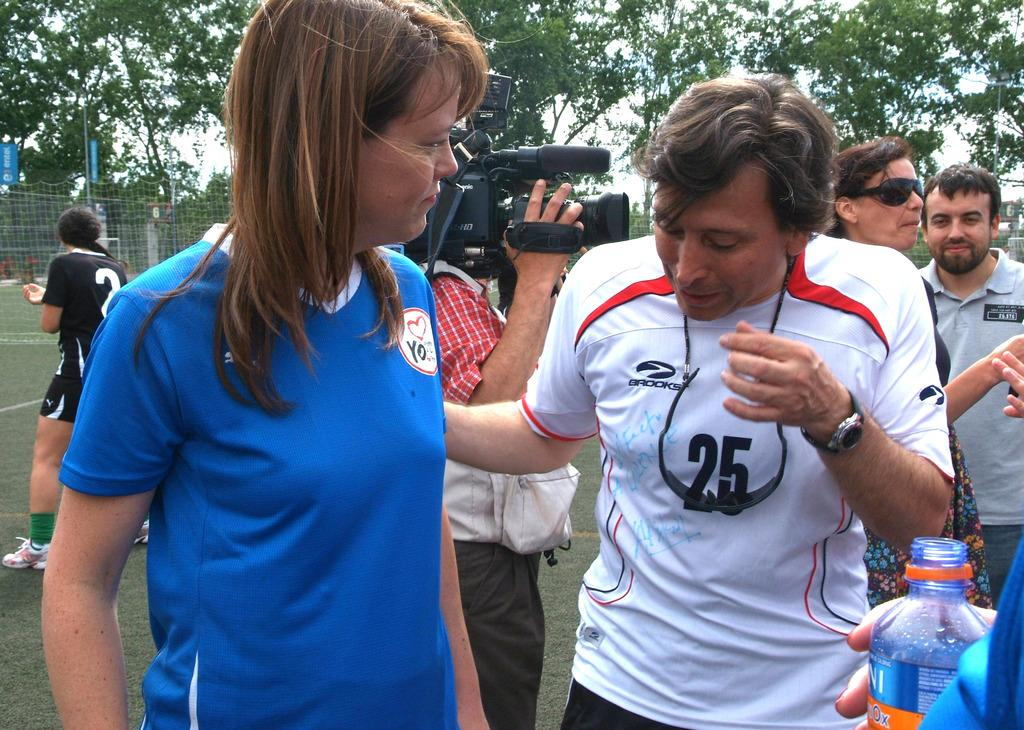Who are the people in the image? There is a man and a woman standing together in the image. What is the third person in the image doing? There is another man standing behind them, holding a camera. What can be seen in the background of the image? There is a fence visible in the image, and trees are at the back of the people. What type of pump can be seen in the image? There is no pump present in the image. How quiet is the environment in the image? The image does not provide any information about the noise level in the environment. 